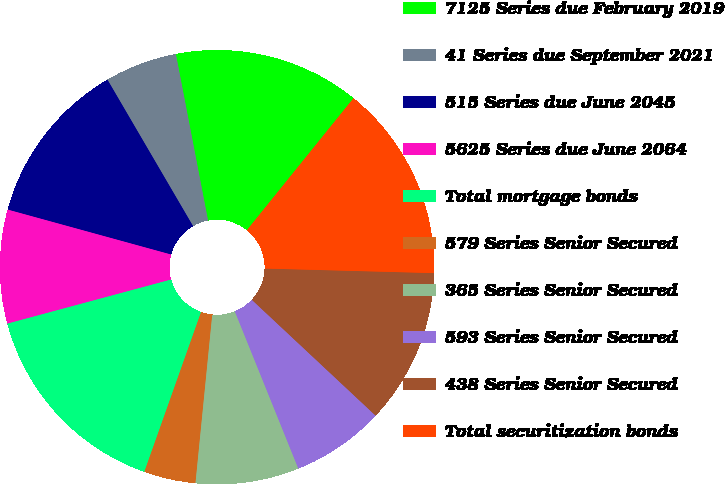Convert chart to OTSL. <chart><loc_0><loc_0><loc_500><loc_500><pie_chart><fcel>7125 Series due February 2019<fcel>41 Series due September 2021<fcel>515 Series due June 2045<fcel>5625 Series due June 2064<fcel>Total mortgage bonds<fcel>579 Series Senior Secured<fcel>365 Series Senior Secured<fcel>593 Series Senior Secured<fcel>438 Series Senior Secured<fcel>Total securitization bonds<nl><fcel>13.85%<fcel>5.38%<fcel>12.31%<fcel>8.46%<fcel>15.38%<fcel>3.85%<fcel>7.69%<fcel>6.92%<fcel>11.54%<fcel>14.62%<nl></chart> 